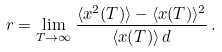Convert formula to latex. <formula><loc_0><loc_0><loc_500><loc_500>r = \lim _ { T \rightarrow \infty } \frac { \langle x ^ { 2 } ( T ) \rangle - \langle x ( T ) \rangle ^ { 2 } } { \langle x ( T ) \rangle \, d } \, .</formula> 